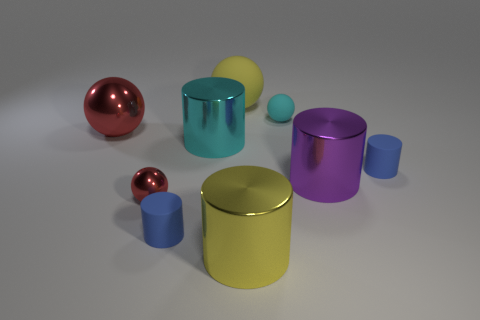Subtract all big purple cylinders. How many cylinders are left? 4 Subtract all green cylinders. Subtract all green spheres. How many cylinders are left? 5 Add 1 yellow spheres. How many objects exist? 10 Subtract all cylinders. How many objects are left? 4 Subtract 0 green cylinders. How many objects are left? 9 Subtract all metal objects. Subtract all large metallic spheres. How many objects are left? 3 Add 5 rubber spheres. How many rubber spheres are left? 7 Add 1 big balls. How many big balls exist? 3 